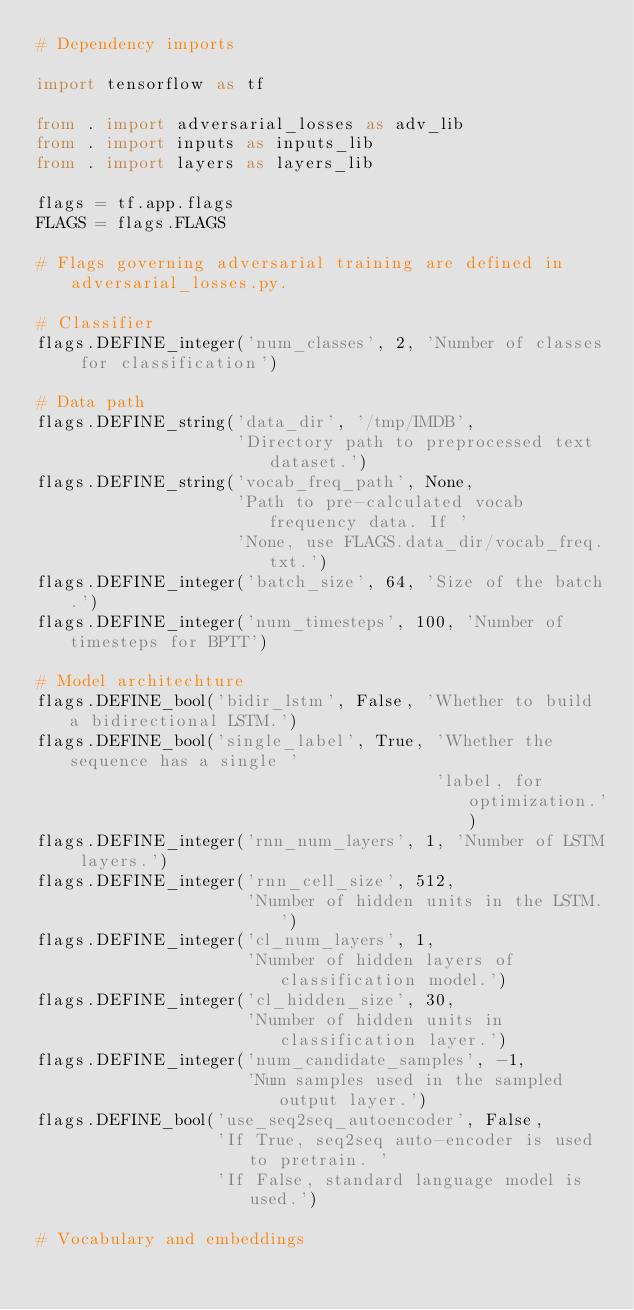<code> <loc_0><loc_0><loc_500><loc_500><_Python_># Dependency imports

import tensorflow as tf

from . import adversarial_losses as adv_lib
from . import inputs as inputs_lib
from . import layers as layers_lib

flags = tf.app.flags
FLAGS = flags.FLAGS

# Flags governing adversarial training are defined in adversarial_losses.py.

# Classifier
flags.DEFINE_integer('num_classes', 2, 'Number of classes for classification')

# Data path
flags.DEFINE_string('data_dir', '/tmp/IMDB',
                    'Directory path to preprocessed text dataset.')
flags.DEFINE_string('vocab_freq_path', None,
                    'Path to pre-calculated vocab frequency data. If '
                    'None, use FLAGS.data_dir/vocab_freq.txt.')
flags.DEFINE_integer('batch_size', 64, 'Size of the batch.')
flags.DEFINE_integer('num_timesteps', 100, 'Number of timesteps for BPTT')

# Model architechture
flags.DEFINE_bool('bidir_lstm', False, 'Whether to build a bidirectional LSTM.')
flags.DEFINE_bool('single_label', True, 'Whether the sequence has a single '
                                        'label, for optimization.')
flags.DEFINE_integer('rnn_num_layers', 1, 'Number of LSTM layers.')
flags.DEFINE_integer('rnn_cell_size', 512,
                     'Number of hidden units in the LSTM.')
flags.DEFINE_integer('cl_num_layers', 1,
                     'Number of hidden layers of classification model.')
flags.DEFINE_integer('cl_hidden_size', 30,
                     'Number of hidden units in classification layer.')
flags.DEFINE_integer('num_candidate_samples', -1,
                     'Num samples used in the sampled output layer.')
flags.DEFINE_bool('use_seq2seq_autoencoder', False,
                  'If True, seq2seq auto-encoder is used to pretrain. '
                  'If False, standard language model is used.')

# Vocabulary and embeddings</code> 